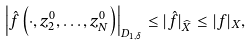Convert formula to latex. <formula><loc_0><loc_0><loc_500><loc_500>\left | \hat { f } \left ( \cdot , z ^ { 0 } _ { 2 } , \dots , z ^ { 0 } _ { N } \right ) \right | _ { D _ { 1 , \delta } } \leq | \hat { f } | _ { \widehat { X } } \leq | f | _ { X } ,</formula> 